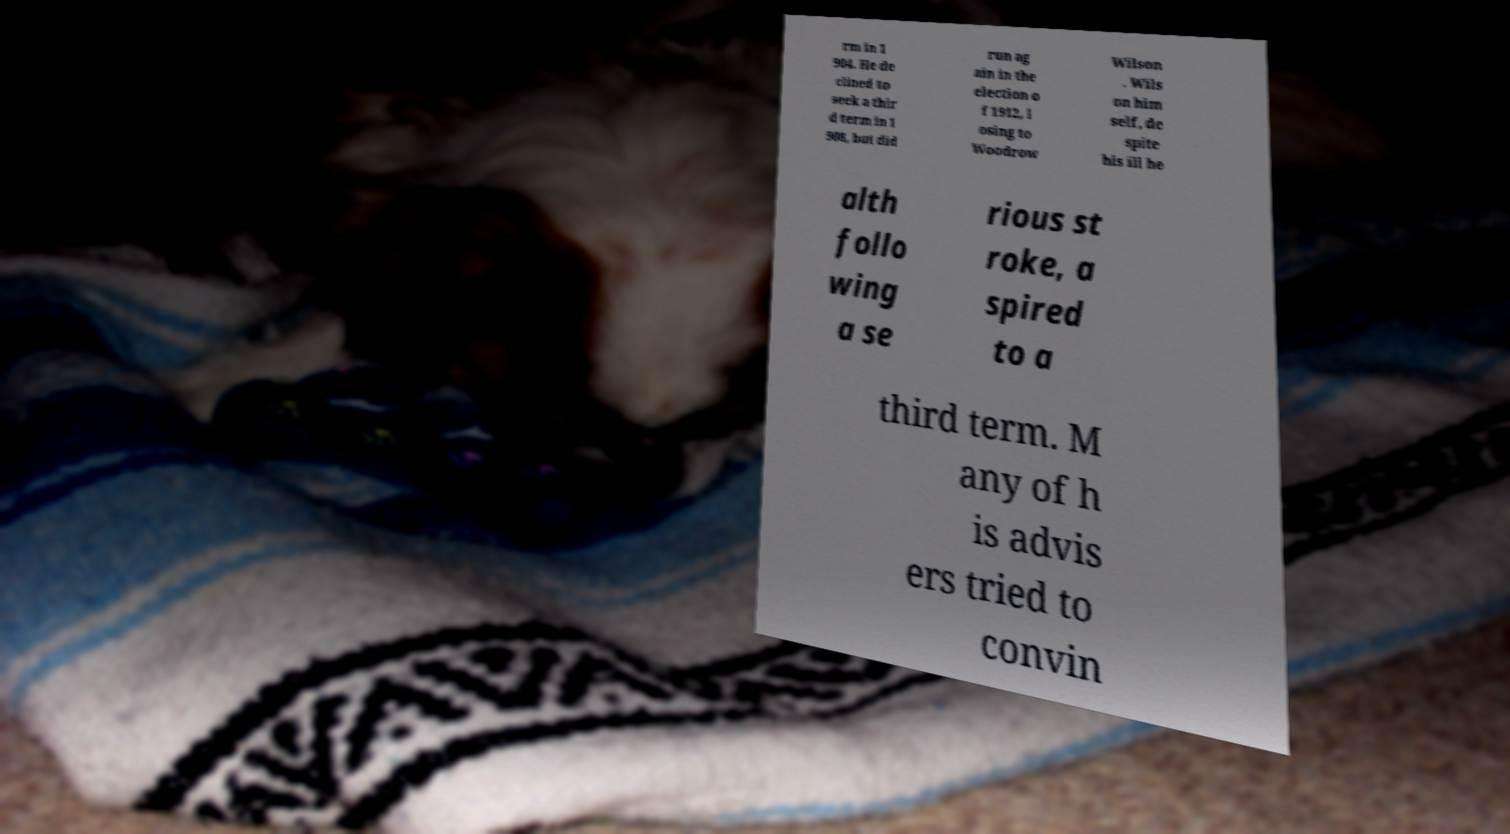For documentation purposes, I need the text within this image transcribed. Could you provide that? rm in 1 904. He de clined to seek a thir d term in 1 908, but did run ag ain in the election o f 1912, l osing to Woodrow Wilson . Wils on him self, de spite his ill he alth follo wing a se rious st roke, a spired to a third term. M any of h is advis ers tried to convin 